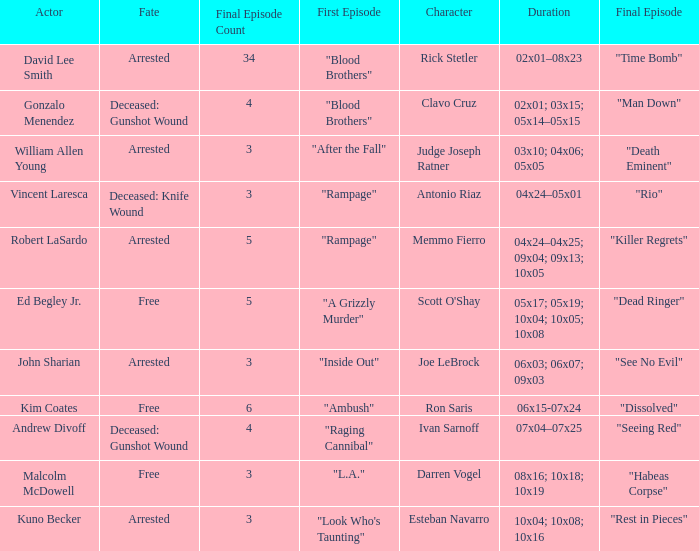Help me parse the entirety of this table. {'header': ['Actor', 'Fate', 'Final Episode Count', 'First Episode', 'Character', 'Duration', 'Final Episode'], 'rows': [['David Lee Smith', 'Arrested', '34', '"Blood Brothers"', 'Rick Stetler', '02x01–08x23', '"Time Bomb"'], ['Gonzalo Menendez', 'Deceased: Gunshot Wound', '4', '"Blood Brothers"', 'Clavo Cruz', '02x01; 03x15; 05x14–05x15', '"Man Down"'], ['William Allen Young', 'Arrested', '3', '"After the Fall"', 'Judge Joseph Ratner', '03x10; 04x06; 05x05', '"Death Eminent"'], ['Vincent Laresca', 'Deceased: Knife Wound', '3', '"Rampage"', 'Antonio Riaz', '04x24–05x01', '"Rio"'], ['Robert LaSardo', 'Arrested', '5', '"Rampage"', 'Memmo Fierro', '04x24–04x25; 09x04; 09x13; 10x05', '"Killer Regrets"'], ['Ed Begley Jr.', 'Free', '5', '"A Grizzly Murder"', "Scott O'Shay", '05x17; 05x19; 10x04; 10x05; 10x08', '"Dead Ringer"'], ['John Sharian', 'Arrested', '3', '"Inside Out"', 'Joe LeBrock', '06x03; 06x07; 09x03', '"See No Evil"'], ['Kim Coates', 'Free', '6', '"Ambush"', 'Ron Saris', '06x15-07x24', '"Dissolved"'], ['Andrew Divoff', 'Deceased: Gunshot Wound', '4', '"Raging Cannibal"', 'Ivan Sarnoff', '07x04–07x25', '"Seeing Red"'], ['Malcolm McDowell', 'Free', '3', '"L.A."', 'Darren Vogel', '08x16; 10x18; 10x19', '"Habeas Corpse"'], ['Kuno Becker', 'Arrested', '3', '"Look Who\'s Taunting"', 'Esteban Navarro', '10x04; 10x08; 10x16', '"Rest in Pieces"']]} What is the overall count of final episodes featuring rick stetler as a character? 1.0. 